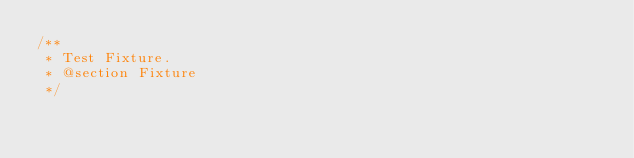<code> <loc_0><loc_0><loc_500><loc_500><_CSS_>/**
 * Test Fixture.
 * @section Fixture
 */</code> 